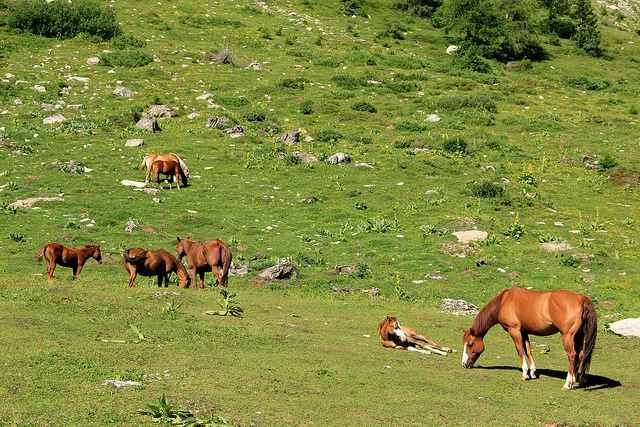Describe the objects in this image and their specific colors. I can see horse in darkgreen, red, brown, black, and orange tones, horse in darkgreen, brown, salmon, black, and maroon tones, horse in darkgreen, black, brown, maroon, and tan tones, horse in darkgreen, tan, black, brown, and ivory tones, and horse in darkgreen, black, maroon, and brown tones in this image. 